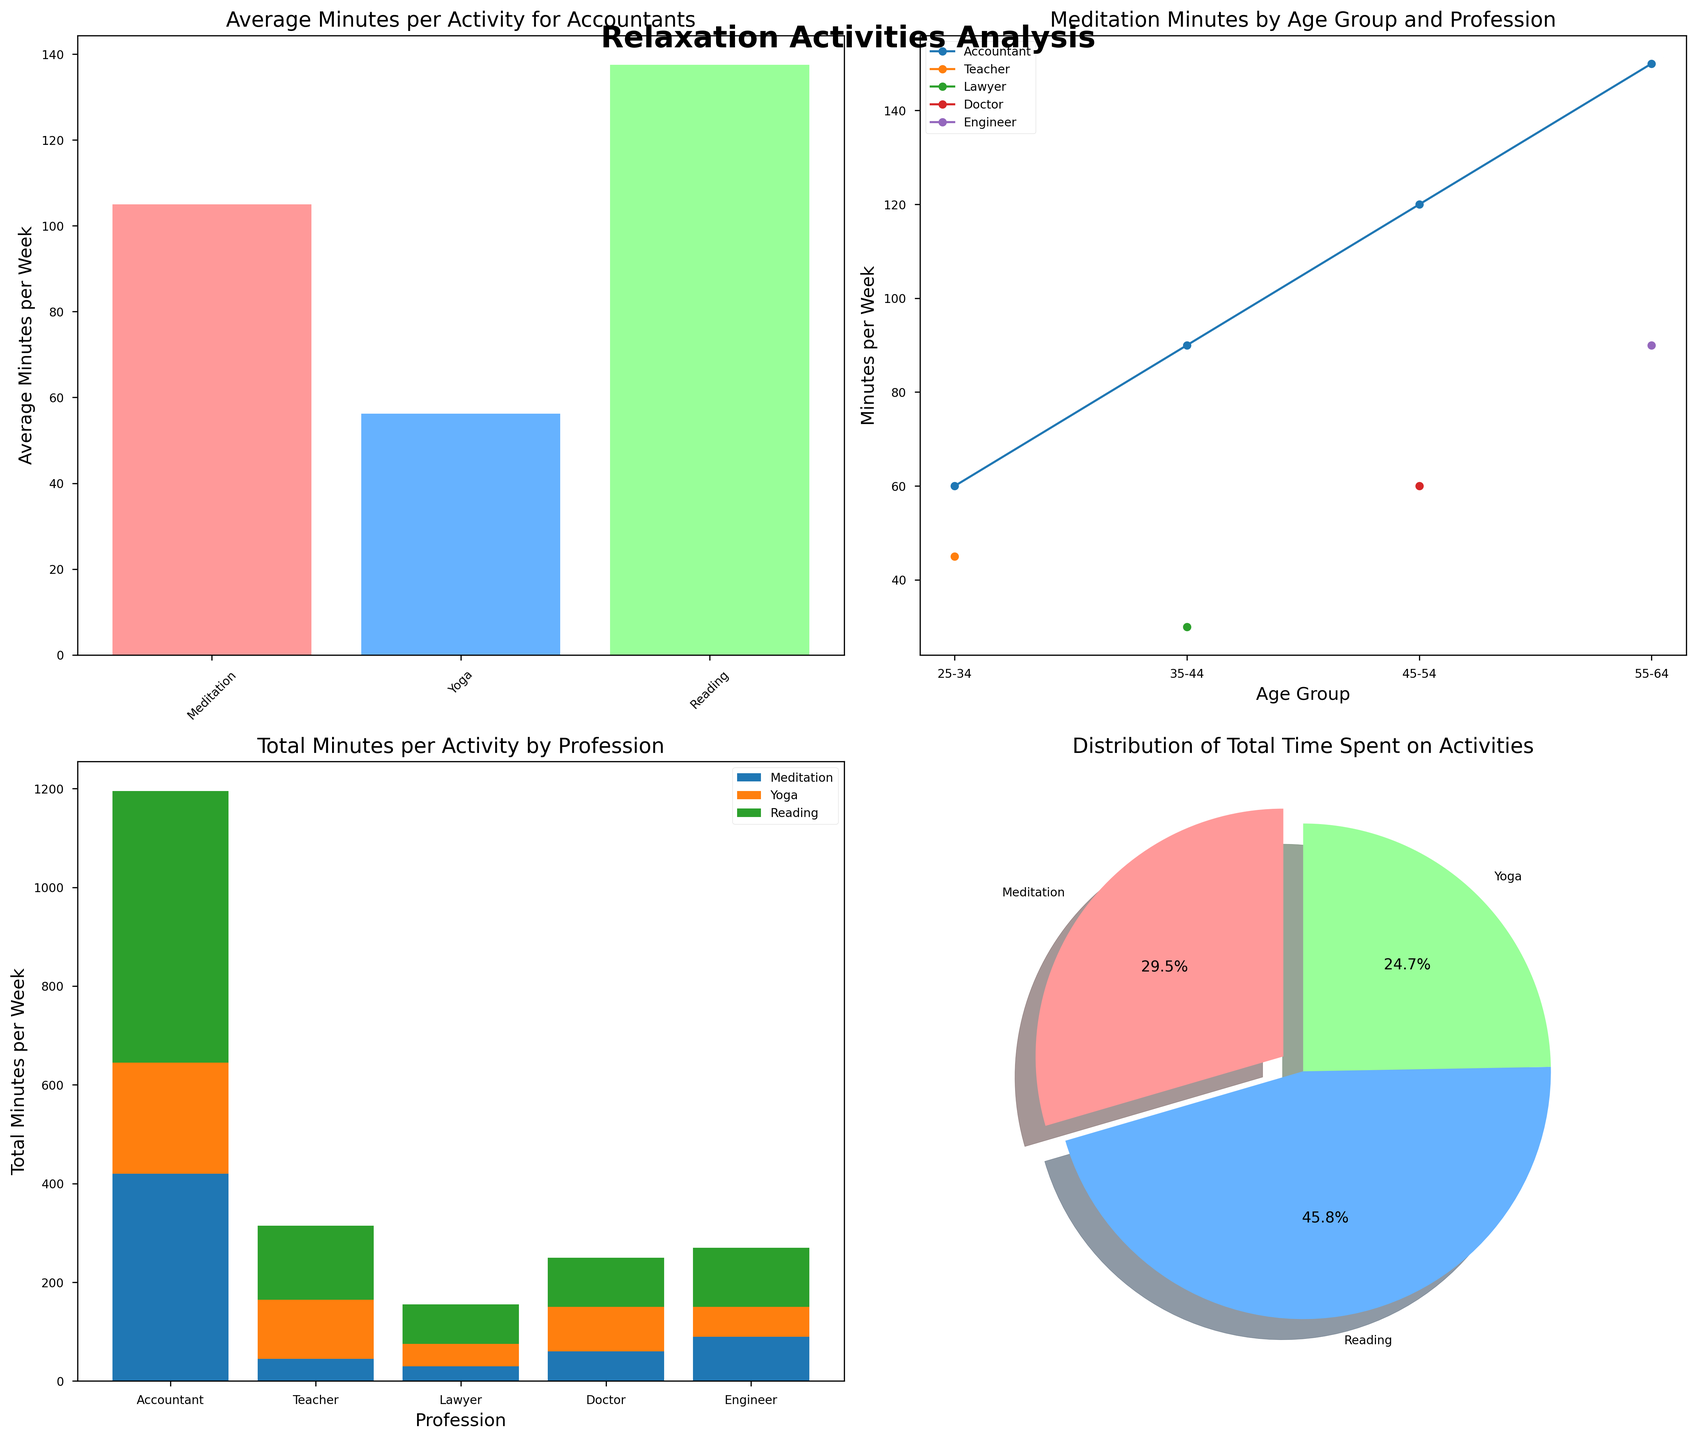What's the title of the subplots figure? The figure's overall title is located above the subplots and is usually styled in a larger or bold font. Here, it says "Relaxation Activities Analysis."
Answer: Relaxation Activities Analysis Which relaxation activity has the highest average minutes per week for Accountants? Look at the bar chart in the first subplot. Identify the tallest bar, which represents "Reading."
Answer: Reading How does the time spent on meditation change with age for Lawyers? Refer to the line chart in the second subplot. Track the line labeled "Lawyer" through the age groups. The time spent decreases from 30 to 0 as the profession ages past 35-44.
Answer: Decreases Comparing Accountants and Engineers, who spends more total time on Yoga? Look at the stacked bar chart in the third subplot. Compare the height of the sections for "Yoga" for both Accountants and Engineers. Accountants spend more time.
Answer: Accountants What percentage of the total time is spent on Yoga across all activities? Check the pie chart in the fourth subplot. The pie slice for Yoga is labeled with its percentage. It is 30.5%.
Answer: 30.5% What's the sum of meditation and yoga minutes per week for the 55-64 age group? Identify the minutes spent on meditation and yoga for 55-64 age group in the dataset: Meditation (150 + 90 = 240) and Yoga (30 + 60 = 90). Add the totals: 240 + 90 = 330 minutes.
Answer: 330 Which profession has the most balanced time distribution among all three activities? Look at the stacked bar chart and evaluate uniformity. Engineers have a visually balanced distribution among Meditation, Yoga, and Reading.
Answer: Engineers How many minutes per week do 45-54-year-old Doctors spend on Reading compared to 25-34-year-old Teachers? Check the dataset: 45-54-year-old Doctors spend 100 minutes, and 25-34-year-old Teachers spend 150 minutes on Reading.
Answer: 100 vs. 150 What is the most common relaxation activity for Teachers in the 25-34 age group? Look at the dataset values for 25-34-year-old Teachers and compare the numbers to see which activity has the highest minutes: Reading is 150 minutes.
Answer: Reading 